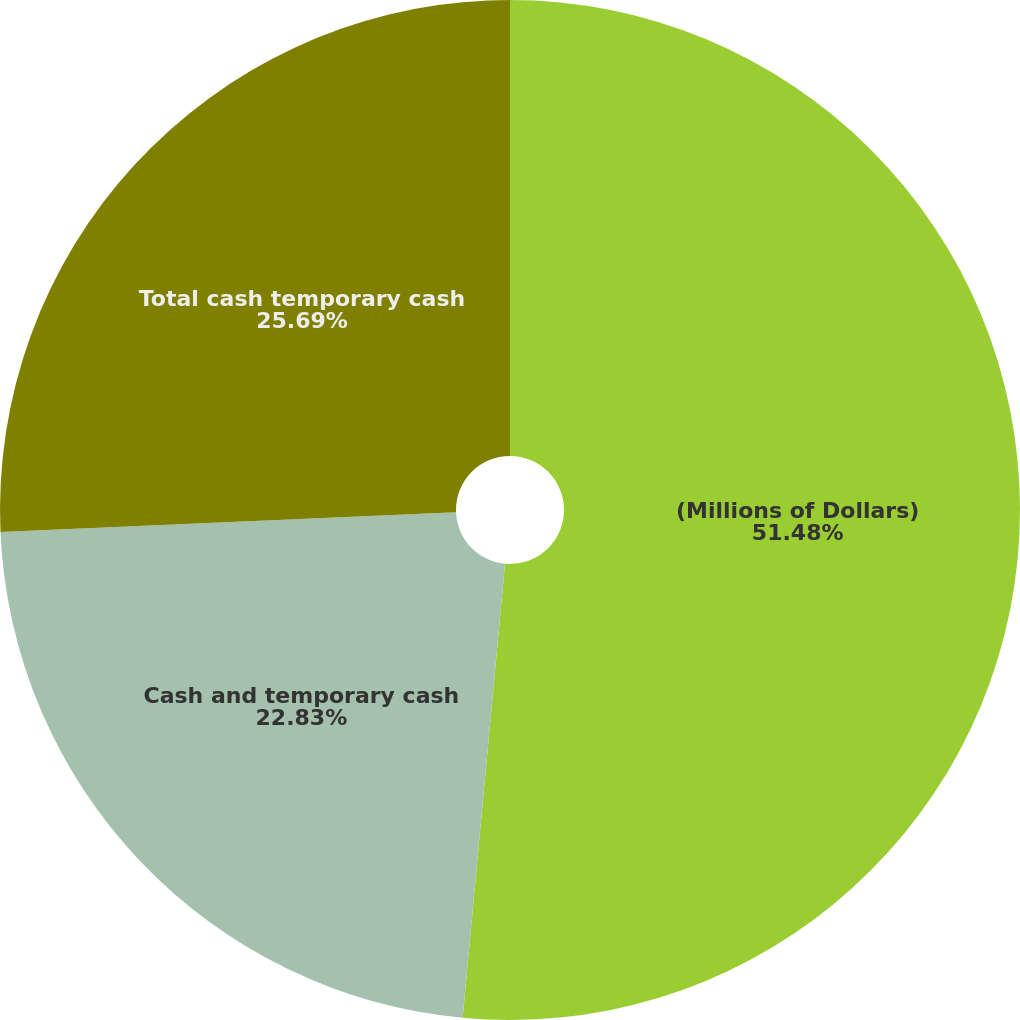Convert chart. <chart><loc_0><loc_0><loc_500><loc_500><pie_chart><fcel>(Millions of Dollars)<fcel>Cash and temporary cash<fcel>Total cash temporary cash<nl><fcel>51.48%<fcel>22.83%<fcel>25.69%<nl></chart> 